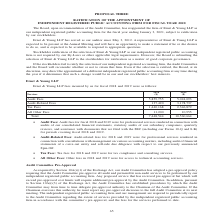From Sunpower Corporation's financial document, What are the components of the fees incurred? The document contains multiple relevant values: Audit Fees, Audit-Related Fees, Tax Fees, All Other Fees. From the document: "Audit Fees 5,859,755 5,024,093 Audit-Related Fees 137,420 3,178,737 Tax Fees 1,440,168 2,346,879 All Other Fees 11,200 10,955..." Also, What are the other fees for in 2018 and 2019? For access to technical accounting services.. The document states: "• All Other Fees: Other fees in 2018 and 2019 were for access to technical accounting services...." Also, What are the tax fees used for? For tax compliance and consulting services.. The document states: "• Tax Fees: Tax fees for 2018 and 2019 were for tax compliance and consulting services...." Additionally, Which year was the tax fees higher? According to the financial document, 2019. The relevant text states: "Services 2018 ($) 2019 ($)..." Also, can you calculate: What was the change in audit fees? Based on the calculation: 5,024,093-5,859,755 , the result is -835662. This is based on the information: "Audit Fees 5,859,755 5,024,093 Audit Fees 5,859,755 5,024,093..." The key data points involved are: 5,024,093, 5,859,755. Also, can you calculate: What was the percentage change in total fees from 2018 to 2019? To answer this question, I need to perform calculations using the financial data. The calculation is: ( 10,560,664 - 7,448,544 )/ 7,448,544 , which equals 41.78 (percentage). This is based on the information: "Total 7,448,544 10,560,664 Total 7,448,544 10,560,664..." The key data points involved are: 10,560,664, 7,448,544. 